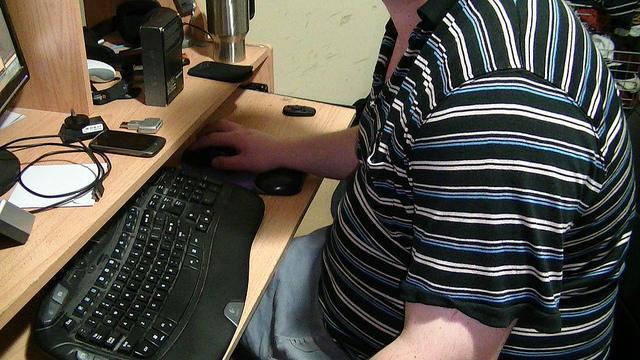Is the caption "The person is at the left side of the tv." a true representation of the image?
Answer yes or no. No. 